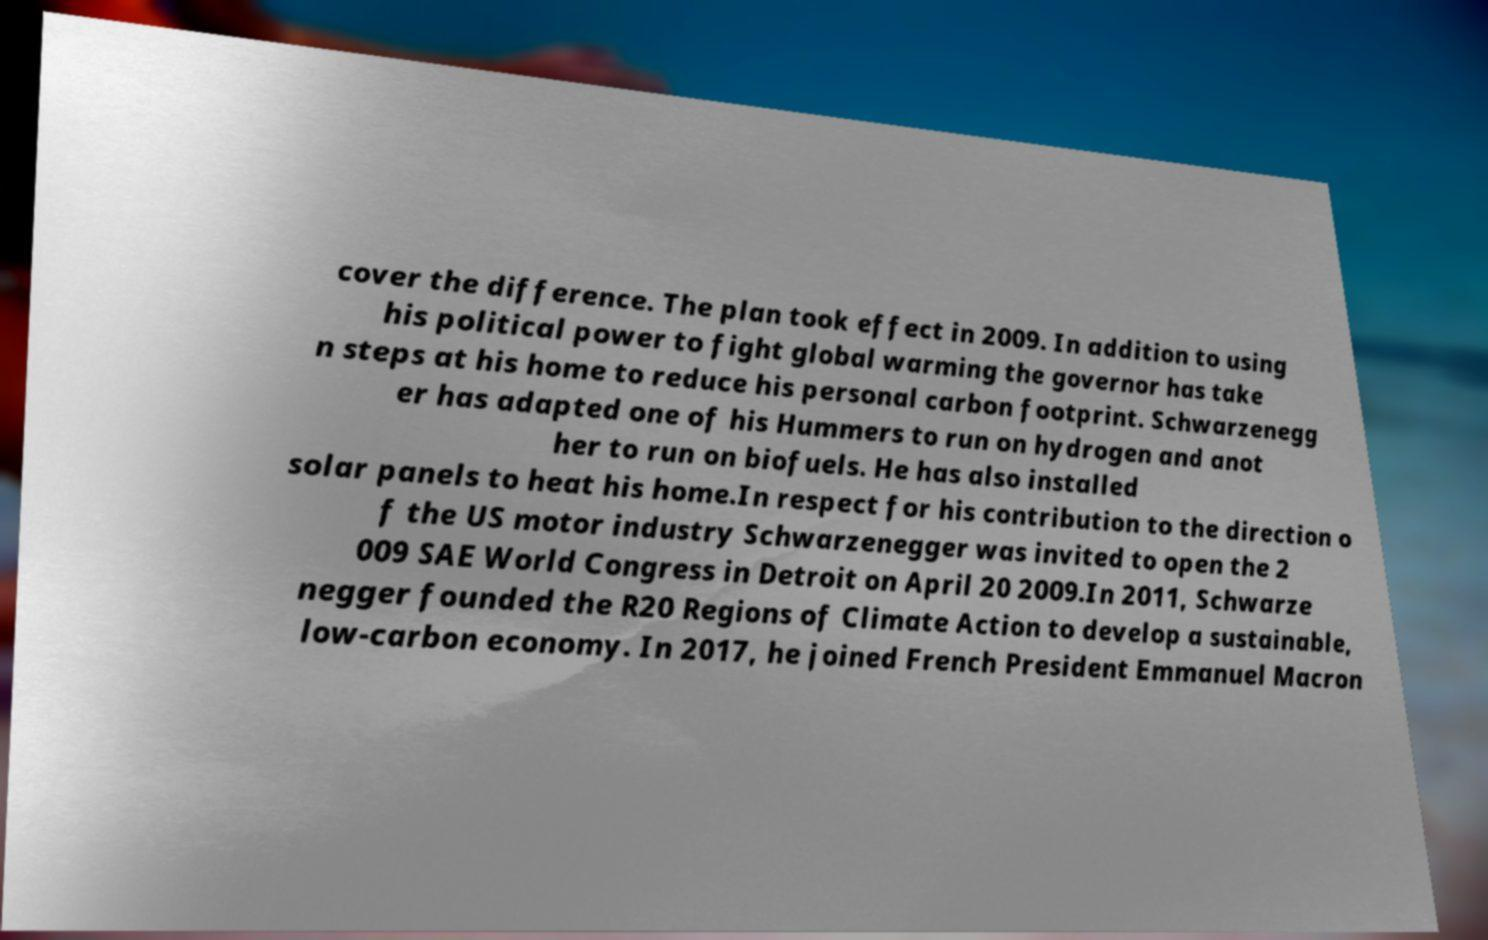I need the written content from this picture converted into text. Can you do that? cover the difference. The plan took effect in 2009. In addition to using his political power to fight global warming the governor has take n steps at his home to reduce his personal carbon footprint. Schwarzenegg er has adapted one of his Hummers to run on hydrogen and anot her to run on biofuels. He has also installed solar panels to heat his home.In respect for his contribution to the direction o f the US motor industry Schwarzenegger was invited to open the 2 009 SAE World Congress in Detroit on April 20 2009.In 2011, Schwarze negger founded the R20 Regions of Climate Action to develop a sustainable, low-carbon economy. In 2017, he joined French President Emmanuel Macron 